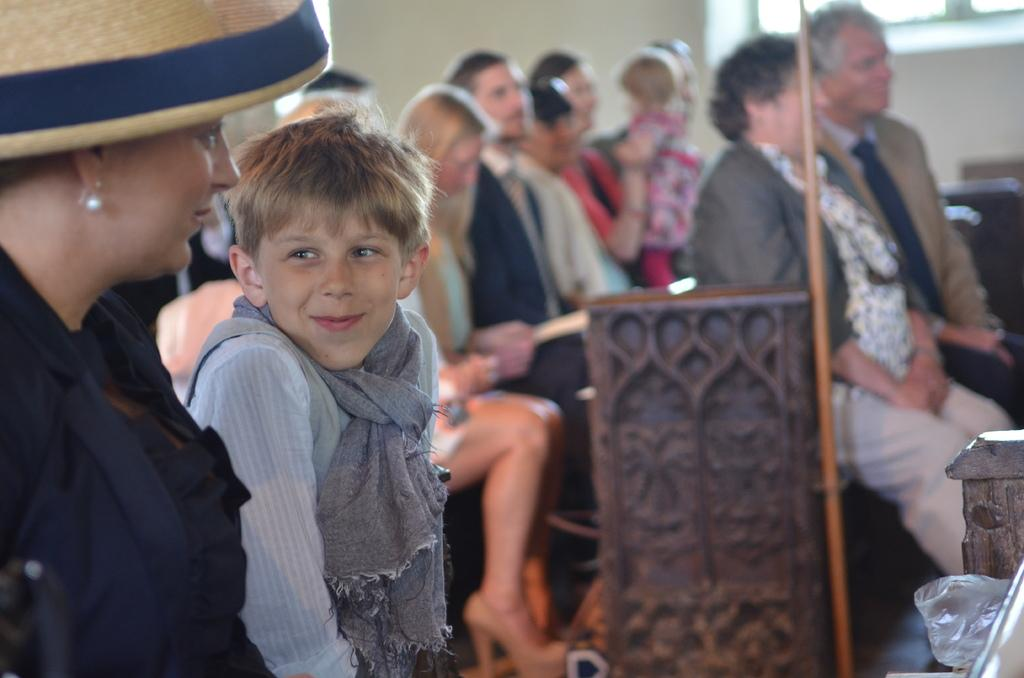What are the people in the image doing? There is a group of people sitting in the image. What can be seen in the background of the image? There is a wall and a window in the background of the image. What is on the floor in the image? There are objects on the floor in the image. What type of linen is being used by the ants in the image? There are no ants present in the image, and therefore no linen being used by them. 